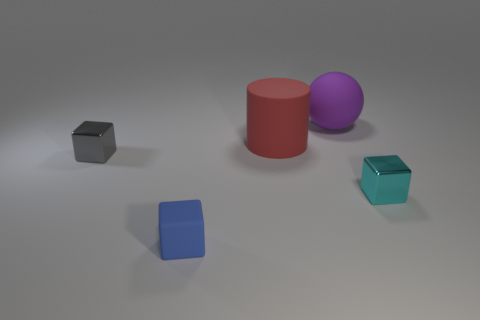What number of objects are shiny cubes in front of the purple thing or gray blocks? In the image, there are two objects that match the criteria: one shiny cube is in front of the purple sphere, and one object is a gray block. So, there are two items in total that fulfill the question's conditions. 